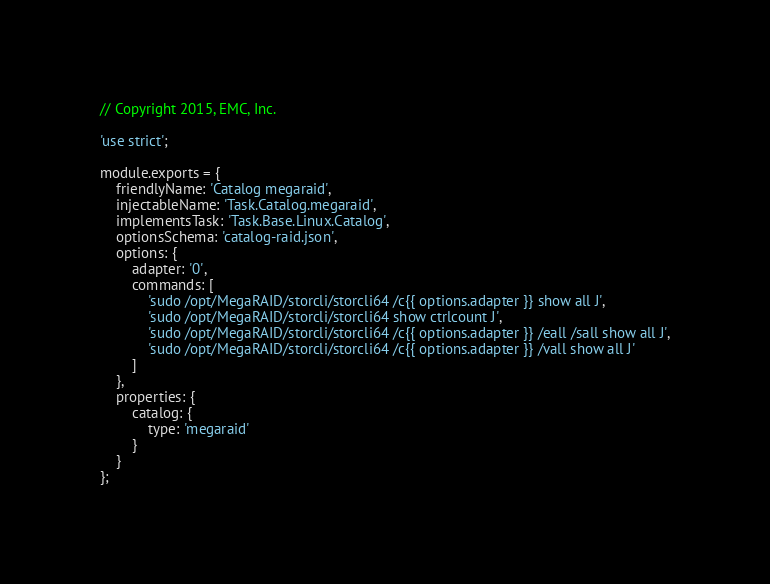<code> <loc_0><loc_0><loc_500><loc_500><_JavaScript_>// Copyright 2015, EMC, Inc.

'use strict';

module.exports = {
    friendlyName: 'Catalog megaraid',
    injectableName: 'Task.Catalog.megaraid',
    implementsTask: 'Task.Base.Linux.Catalog',
    optionsSchema: 'catalog-raid.json',
    options: {
        adapter: '0',
        commands: [
            'sudo /opt/MegaRAID/storcli/storcli64 /c{{ options.adapter }} show all J',
            'sudo /opt/MegaRAID/storcli/storcli64 show ctrlcount J',
            'sudo /opt/MegaRAID/storcli/storcli64 /c{{ options.adapter }} /eall /sall show all J',
            'sudo /opt/MegaRAID/storcli/storcli64 /c{{ options.adapter }} /vall show all J'
        ]
    },
    properties: {
        catalog: {
            type: 'megaraid'
        }
    }
};
</code> 